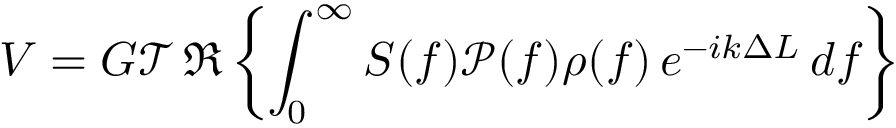<formula> <loc_0><loc_0><loc_500><loc_500>V = G \mathcal { T } \Re \left \{ \int _ { 0 } ^ { \infty } S ( f ) \mathcal { P } ( f ) \rho ( f ) e ^ { - i k \Delta L } d f \right \}</formula> 